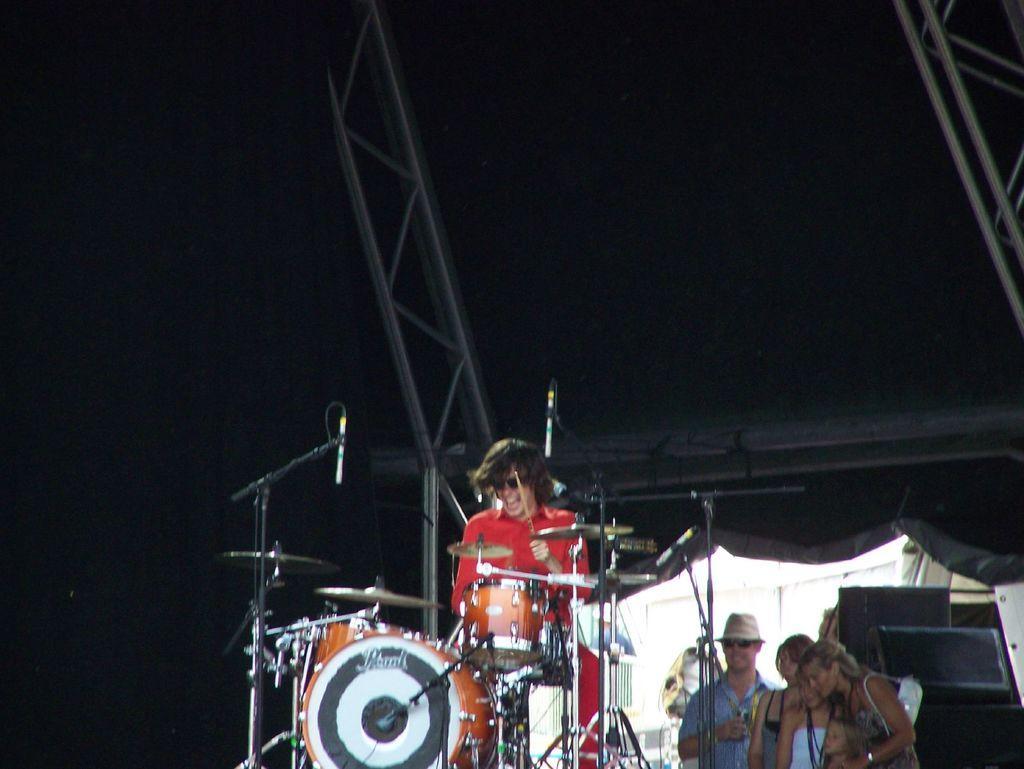How would you summarize this image in a sentence or two? This is the picture of a person on the stage who is playing some musical instrument and there are three people behind him. 